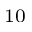Convert formula to latex. <formula><loc_0><loc_0><loc_500><loc_500>_ { 1 0 }</formula> 